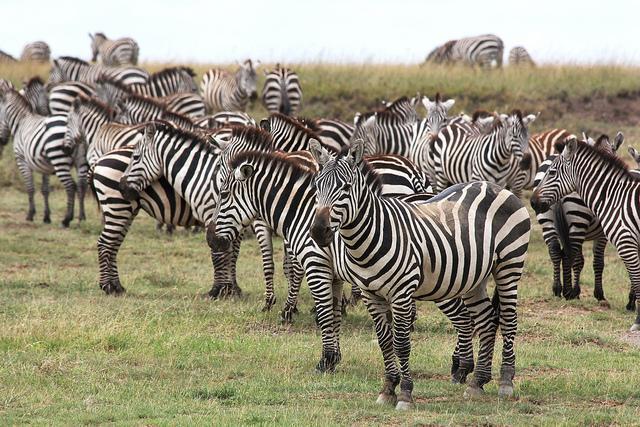How many zebras are there?
Give a very brief answer. 8. How many people are on bikes?
Give a very brief answer. 0. 